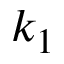Convert formula to latex. <formula><loc_0><loc_0><loc_500><loc_500>k _ { 1 }</formula> 